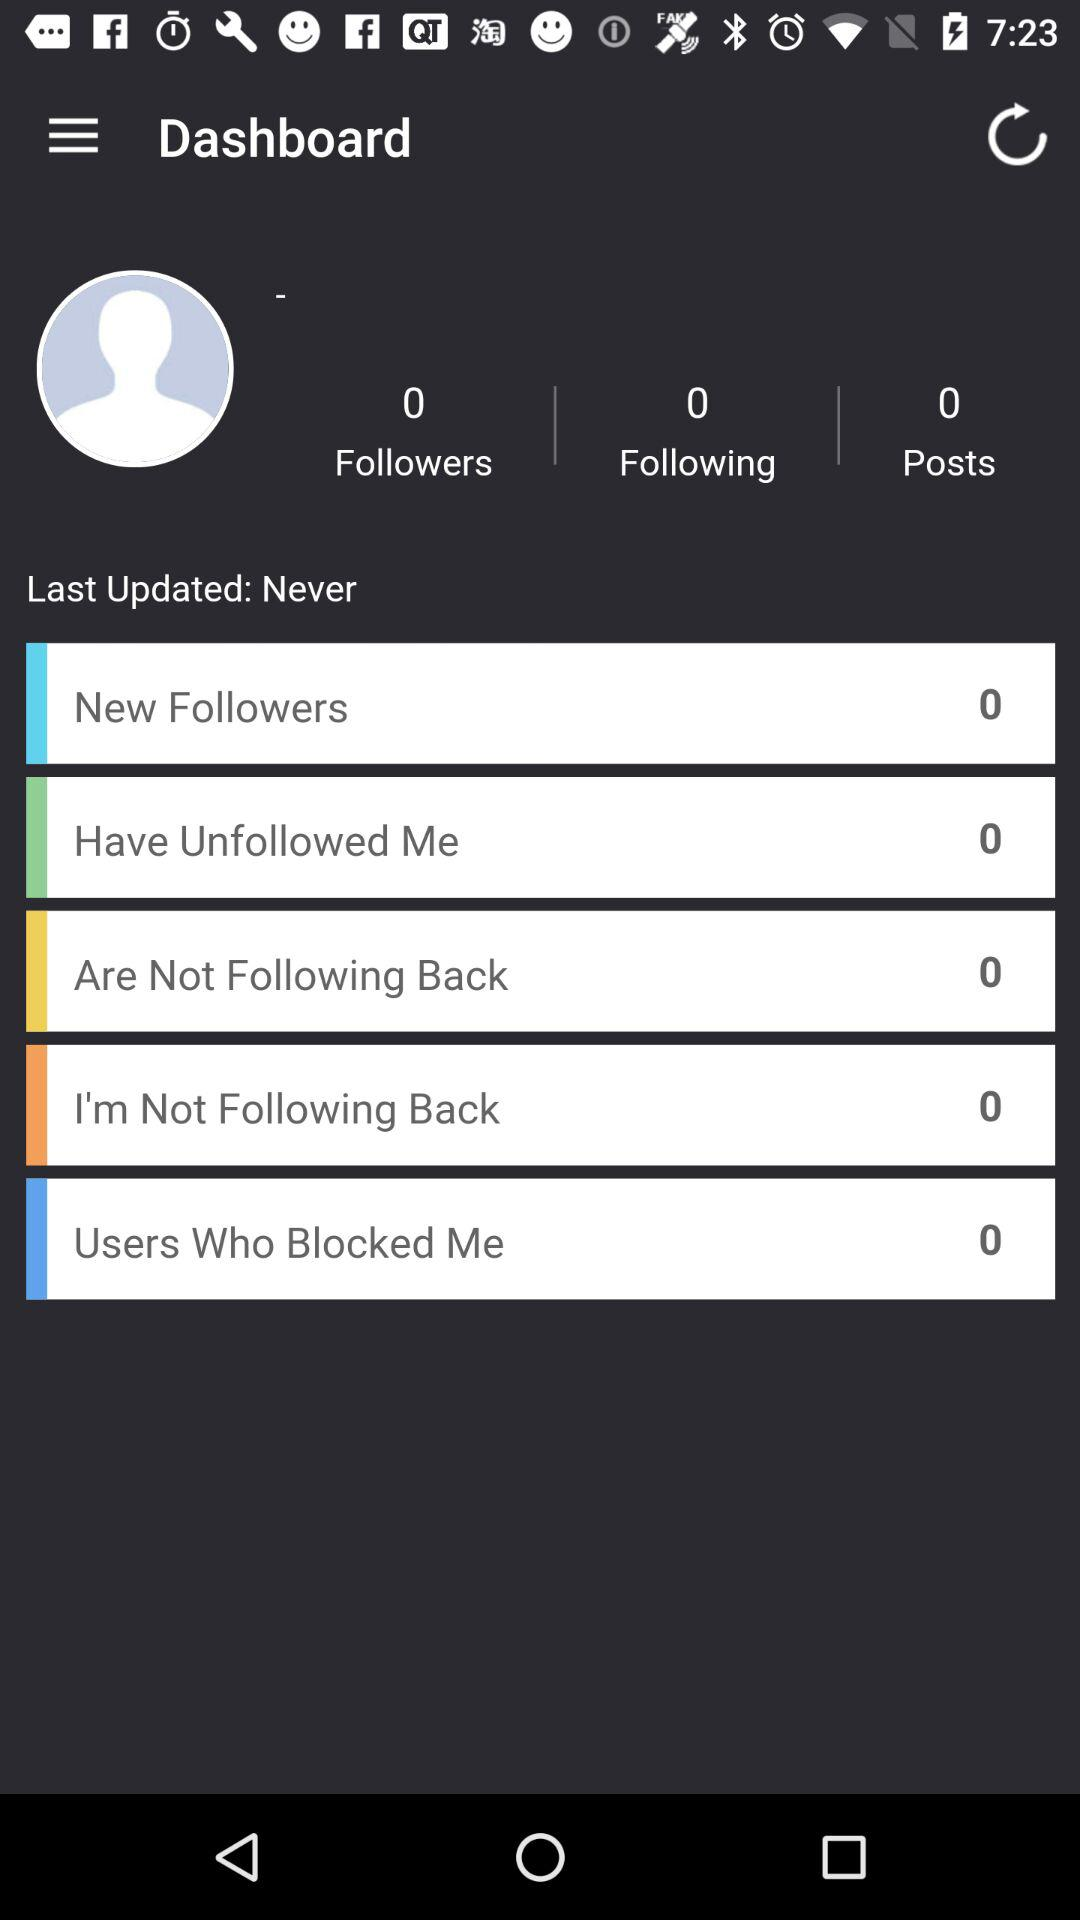What is the total number of posts that have been shared? The total number of posts that have been shared is 0. 